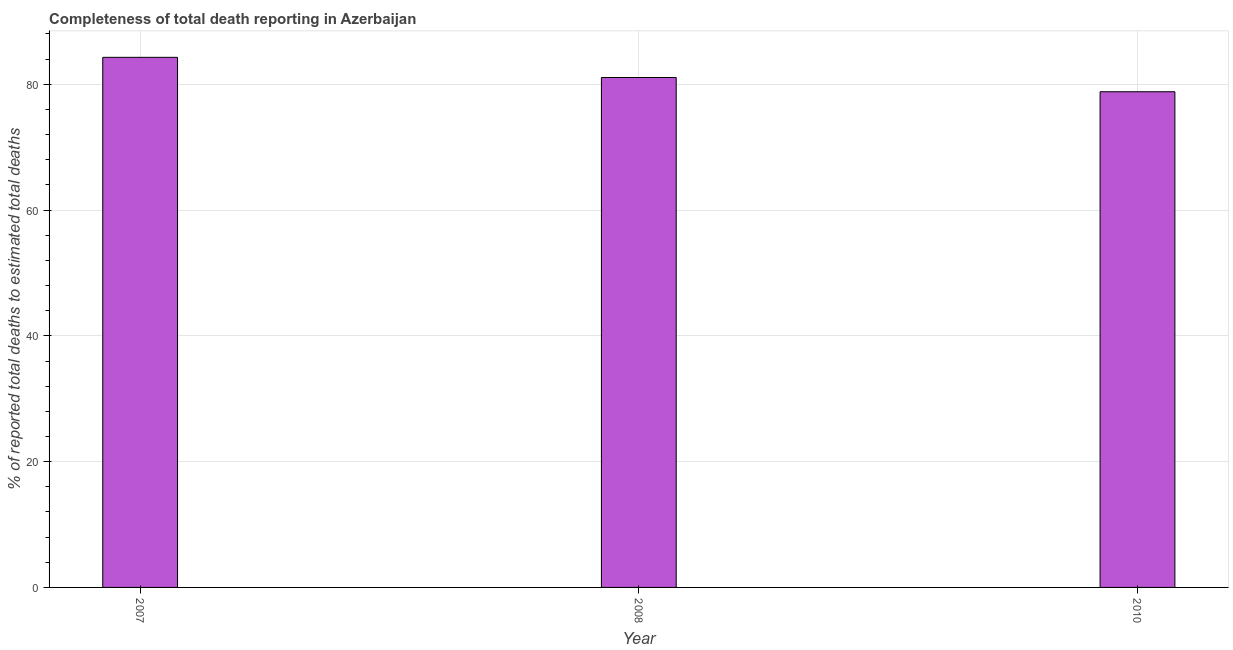What is the title of the graph?
Give a very brief answer. Completeness of total death reporting in Azerbaijan. What is the label or title of the X-axis?
Your response must be concise. Year. What is the label or title of the Y-axis?
Offer a terse response. % of reported total deaths to estimated total deaths. What is the completeness of total death reports in 2008?
Provide a short and direct response. 81.08. Across all years, what is the maximum completeness of total death reports?
Ensure brevity in your answer.  84.29. Across all years, what is the minimum completeness of total death reports?
Offer a terse response. 78.82. In which year was the completeness of total death reports minimum?
Your answer should be compact. 2010. What is the sum of the completeness of total death reports?
Provide a short and direct response. 244.19. What is the difference between the completeness of total death reports in 2007 and 2010?
Keep it short and to the point. 5.47. What is the average completeness of total death reports per year?
Keep it short and to the point. 81.4. What is the median completeness of total death reports?
Provide a short and direct response. 81.08. In how many years, is the completeness of total death reports greater than 80 %?
Make the answer very short. 2. What is the ratio of the completeness of total death reports in 2007 to that in 2008?
Provide a succinct answer. 1.04. Is the completeness of total death reports in 2007 less than that in 2008?
Your answer should be very brief. No. Is the difference between the completeness of total death reports in 2007 and 2010 greater than the difference between any two years?
Provide a short and direct response. Yes. What is the difference between the highest and the second highest completeness of total death reports?
Your answer should be very brief. 3.21. What is the difference between the highest and the lowest completeness of total death reports?
Offer a terse response. 5.47. How many bars are there?
Your answer should be compact. 3. How many years are there in the graph?
Keep it short and to the point. 3. What is the difference between two consecutive major ticks on the Y-axis?
Offer a terse response. 20. Are the values on the major ticks of Y-axis written in scientific E-notation?
Offer a terse response. No. What is the % of reported total deaths to estimated total deaths in 2007?
Ensure brevity in your answer.  84.29. What is the % of reported total deaths to estimated total deaths in 2008?
Make the answer very short. 81.08. What is the % of reported total deaths to estimated total deaths in 2010?
Offer a terse response. 78.82. What is the difference between the % of reported total deaths to estimated total deaths in 2007 and 2008?
Your response must be concise. 3.21. What is the difference between the % of reported total deaths to estimated total deaths in 2007 and 2010?
Keep it short and to the point. 5.47. What is the difference between the % of reported total deaths to estimated total deaths in 2008 and 2010?
Provide a short and direct response. 2.26. What is the ratio of the % of reported total deaths to estimated total deaths in 2007 to that in 2008?
Your answer should be very brief. 1.04. What is the ratio of the % of reported total deaths to estimated total deaths in 2007 to that in 2010?
Provide a short and direct response. 1.07. 